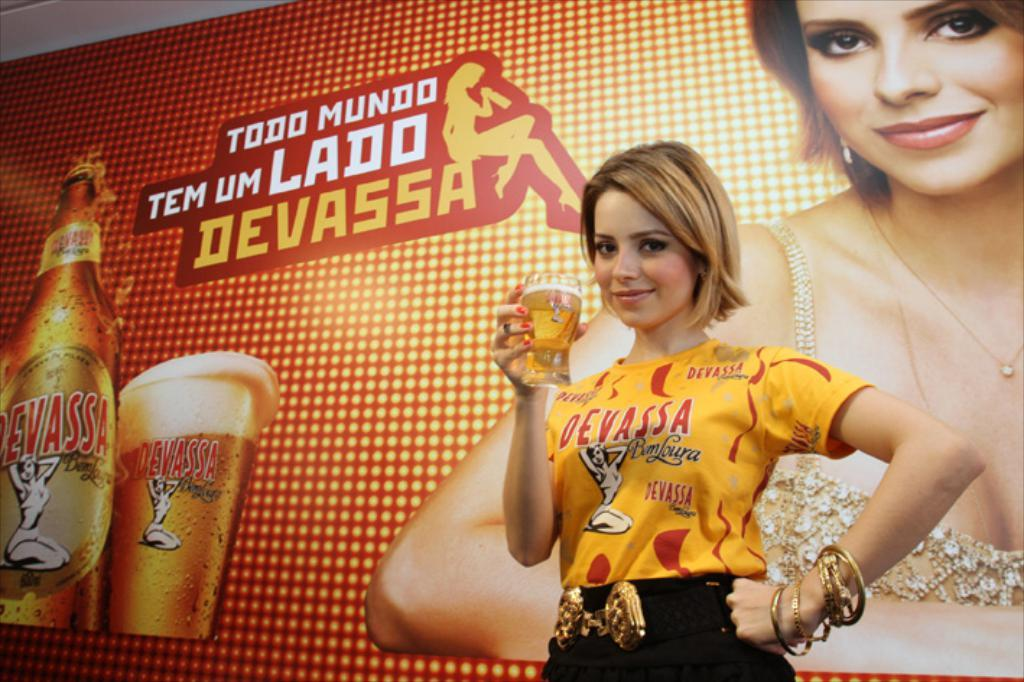Provide a one-sentence caption for the provided image. Devassa lager is being advertised by a pretty lady drinking a glassful, infront of a big banner devoted to her picture and the product. 